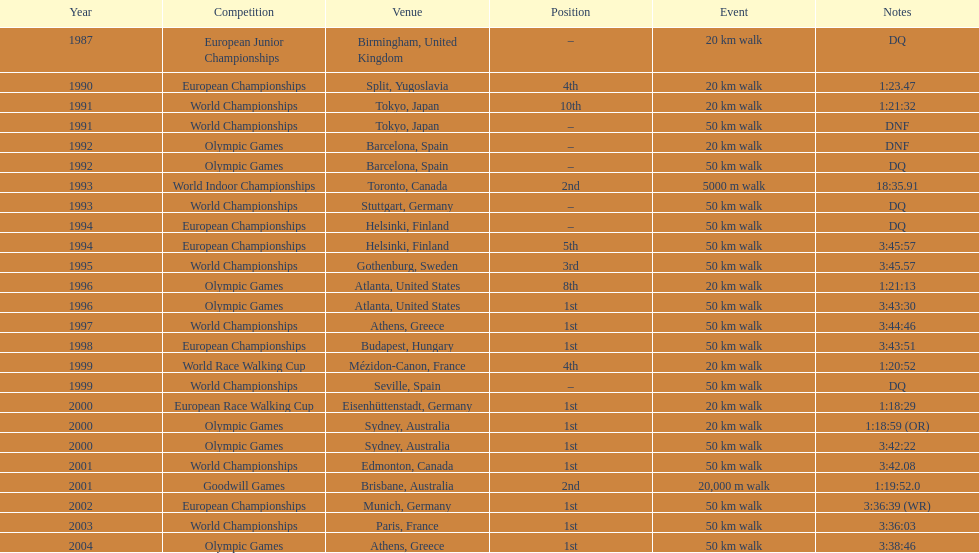Write the full table. {'header': ['Year', 'Competition', 'Venue', 'Position', 'Event', 'Notes'], 'rows': [['1987', 'European Junior Championships', 'Birmingham, United Kingdom', '–', '20\xa0km walk', 'DQ'], ['1990', 'European Championships', 'Split, Yugoslavia', '4th', '20\xa0km walk', '1:23.47'], ['1991', 'World Championships', 'Tokyo, Japan', '10th', '20\xa0km walk', '1:21:32'], ['1991', 'World Championships', 'Tokyo, Japan', '–', '50\xa0km walk', 'DNF'], ['1992', 'Olympic Games', 'Barcelona, Spain', '–', '20\xa0km walk', 'DNF'], ['1992', 'Olympic Games', 'Barcelona, Spain', '–', '50\xa0km walk', 'DQ'], ['1993', 'World Indoor Championships', 'Toronto, Canada', '2nd', '5000 m walk', '18:35.91'], ['1993', 'World Championships', 'Stuttgart, Germany', '–', '50\xa0km walk', 'DQ'], ['1994', 'European Championships', 'Helsinki, Finland', '–', '50\xa0km walk', 'DQ'], ['1994', 'European Championships', 'Helsinki, Finland', '5th', '50\xa0km walk', '3:45:57'], ['1995', 'World Championships', 'Gothenburg, Sweden', '3rd', '50\xa0km walk', '3:45.57'], ['1996', 'Olympic Games', 'Atlanta, United States', '8th', '20\xa0km walk', '1:21:13'], ['1996', 'Olympic Games', 'Atlanta, United States', '1st', '50\xa0km walk', '3:43:30'], ['1997', 'World Championships', 'Athens, Greece', '1st', '50\xa0km walk', '3:44:46'], ['1998', 'European Championships', 'Budapest, Hungary', '1st', '50\xa0km walk', '3:43:51'], ['1999', 'World Race Walking Cup', 'Mézidon-Canon, France', '4th', '20\xa0km walk', '1:20:52'], ['1999', 'World Championships', 'Seville, Spain', '–', '50\xa0km walk', 'DQ'], ['2000', 'European Race Walking Cup', 'Eisenhüttenstadt, Germany', '1st', '20\xa0km walk', '1:18:29'], ['2000', 'Olympic Games', 'Sydney, Australia', '1st', '20\xa0km walk', '1:18:59 (OR)'], ['2000', 'Olympic Games', 'Sydney, Australia', '1st', '50\xa0km walk', '3:42:22'], ['2001', 'World Championships', 'Edmonton, Canada', '1st', '50\xa0km walk', '3:42.08'], ['2001', 'Goodwill Games', 'Brisbane, Australia', '2nd', '20,000 m walk', '1:19:52.0'], ['2002', 'European Championships', 'Munich, Germany', '1st', '50\xa0km walk', '3:36:39 (WR)'], ['2003', 'World Championships', 'Paris, France', '1st', '50\xa0km walk', '3:36:03'], ['2004', 'Olympic Games', 'Athens, Greece', '1st', '50\xa0km walk', '3:38:46']]} How many instances was the top spot indicated as the position? 10. 